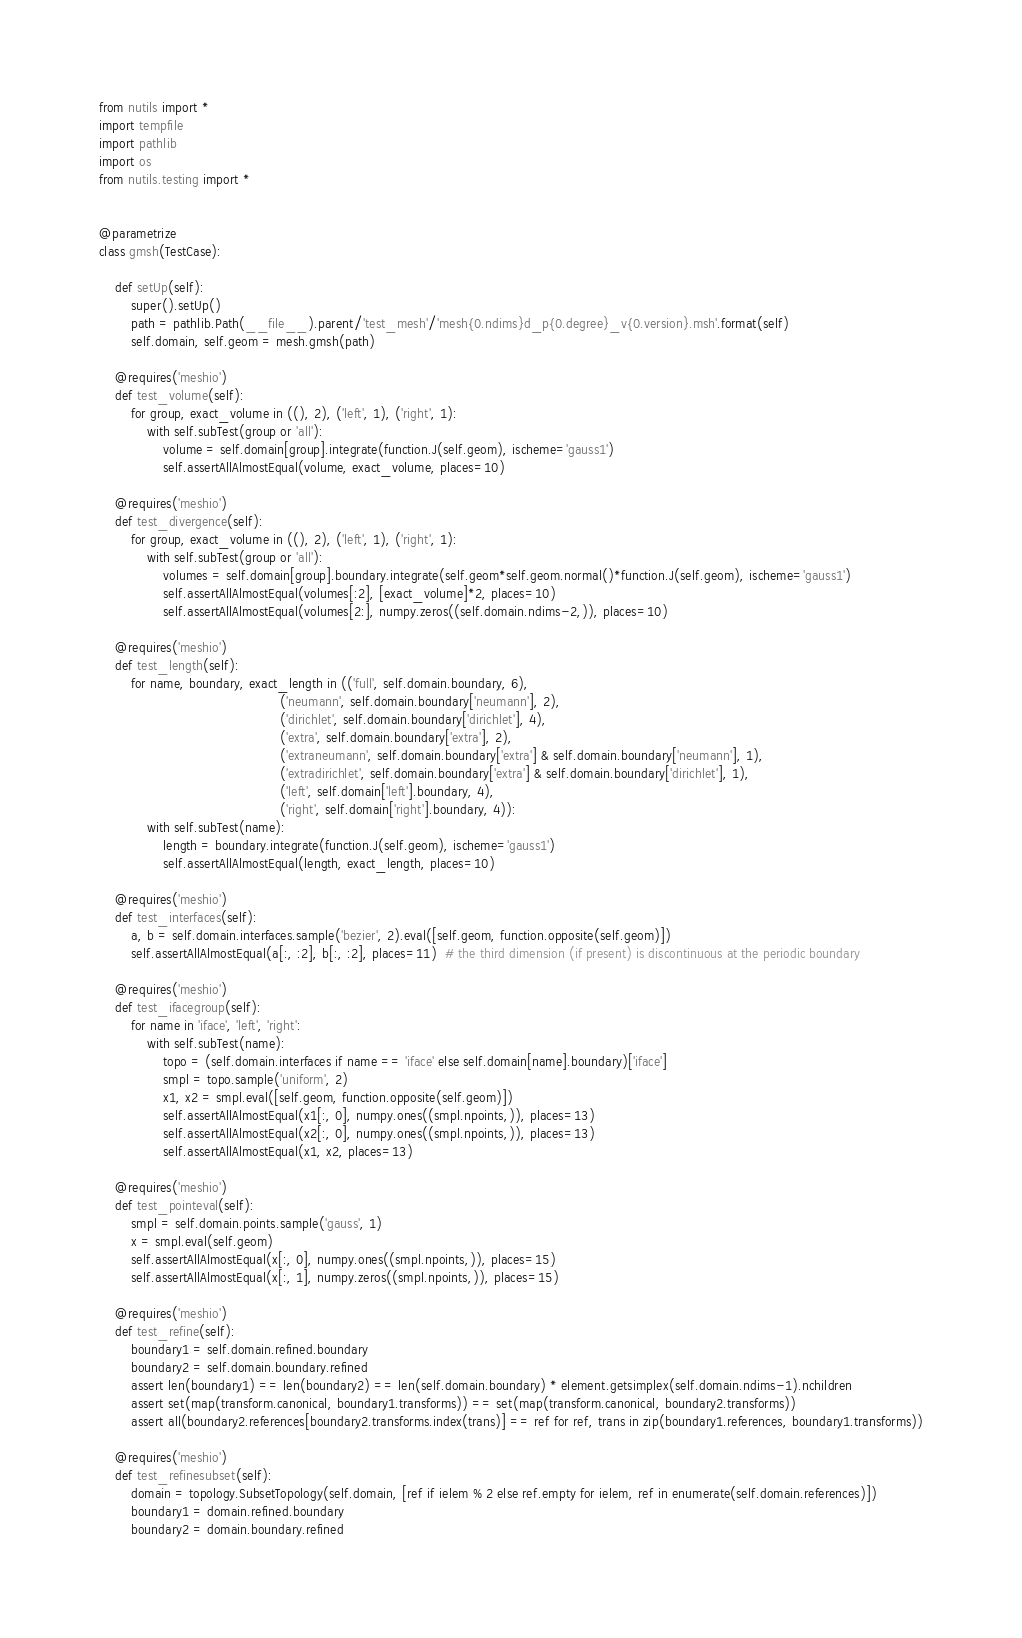<code> <loc_0><loc_0><loc_500><loc_500><_Python_>from nutils import *
import tempfile
import pathlib
import os
from nutils.testing import *


@parametrize
class gmsh(TestCase):

    def setUp(self):
        super().setUp()
        path = pathlib.Path(__file__).parent/'test_mesh'/'mesh{0.ndims}d_p{0.degree}_v{0.version}.msh'.format(self)
        self.domain, self.geom = mesh.gmsh(path)

    @requires('meshio')
    def test_volume(self):
        for group, exact_volume in ((), 2), ('left', 1), ('right', 1):
            with self.subTest(group or 'all'):
                volume = self.domain[group].integrate(function.J(self.geom), ischeme='gauss1')
                self.assertAllAlmostEqual(volume, exact_volume, places=10)

    @requires('meshio')
    def test_divergence(self):
        for group, exact_volume in ((), 2), ('left', 1), ('right', 1):
            with self.subTest(group or 'all'):
                volumes = self.domain[group].boundary.integrate(self.geom*self.geom.normal()*function.J(self.geom), ischeme='gauss1')
                self.assertAllAlmostEqual(volumes[:2], [exact_volume]*2, places=10)
                self.assertAllAlmostEqual(volumes[2:], numpy.zeros((self.domain.ndims-2,)), places=10)

    @requires('meshio')
    def test_length(self):
        for name, boundary, exact_length in (('full', self.domain.boundary, 6),
                                             ('neumann', self.domain.boundary['neumann'], 2),
                                             ('dirichlet', self.domain.boundary['dirichlet'], 4),
                                             ('extra', self.domain.boundary['extra'], 2),
                                             ('extraneumann', self.domain.boundary['extra'] & self.domain.boundary['neumann'], 1),
                                             ('extradirichlet', self.domain.boundary['extra'] & self.domain.boundary['dirichlet'], 1),
                                             ('left', self.domain['left'].boundary, 4),
                                             ('right', self.domain['right'].boundary, 4)):
            with self.subTest(name):
                length = boundary.integrate(function.J(self.geom), ischeme='gauss1')
                self.assertAllAlmostEqual(length, exact_length, places=10)

    @requires('meshio')
    def test_interfaces(self):
        a, b = self.domain.interfaces.sample('bezier', 2).eval([self.geom, function.opposite(self.geom)])
        self.assertAllAlmostEqual(a[:, :2], b[:, :2], places=11)  # the third dimension (if present) is discontinuous at the periodic boundary

    @requires('meshio')
    def test_ifacegroup(self):
        for name in 'iface', 'left', 'right':
            with self.subTest(name):
                topo = (self.domain.interfaces if name == 'iface' else self.domain[name].boundary)['iface']
                smpl = topo.sample('uniform', 2)
                x1, x2 = smpl.eval([self.geom, function.opposite(self.geom)])
                self.assertAllAlmostEqual(x1[:, 0], numpy.ones((smpl.npoints,)), places=13)
                self.assertAllAlmostEqual(x2[:, 0], numpy.ones((smpl.npoints,)), places=13)
                self.assertAllAlmostEqual(x1, x2, places=13)

    @requires('meshio')
    def test_pointeval(self):
        smpl = self.domain.points.sample('gauss', 1)
        x = smpl.eval(self.geom)
        self.assertAllAlmostEqual(x[:, 0], numpy.ones((smpl.npoints,)), places=15)
        self.assertAllAlmostEqual(x[:, 1], numpy.zeros((smpl.npoints,)), places=15)

    @requires('meshio')
    def test_refine(self):
        boundary1 = self.domain.refined.boundary
        boundary2 = self.domain.boundary.refined
        assert len(boundary1) == len(boundary2) == len(self.domain.boundary) * element.getsimplex(self.domain.ndims-1).nchildren
        assert set(map(transform.canonical, boundary1.transforms)) == set(map(transform.canonical, boundary2.transforms))
        assert all(boundary2.references[boundary2.transforms.index(trans)] == ref for ref, trans in zip(boundary1.references, boundary1.transforms))

    @requires('meshio')
    def test_refinesubset(self):
        domain = topology.SubsetTopology(self.domain, [ref if ielem % 2 else ref.empty for ielem, ref in enumerate(self.domain.references)])
        boundary1 = domain.refined.boundary
        boundary2 = domain.boundary.refined</code> 